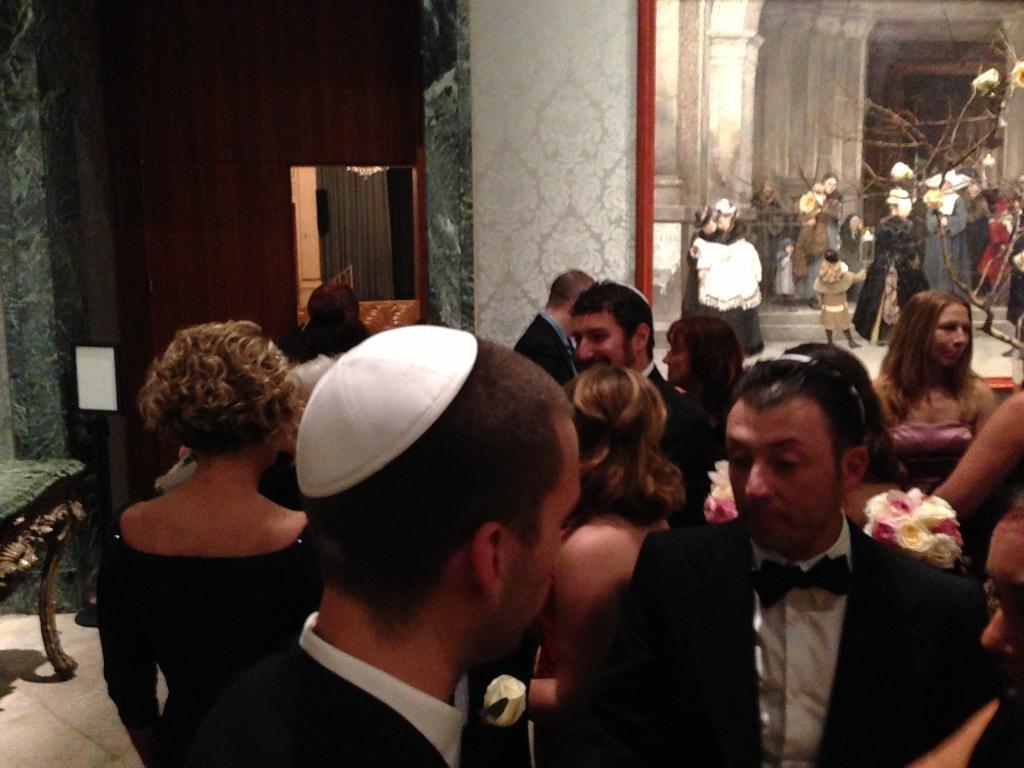How many people are in the image? There is a group of people in the image, but the exact number is not specified. What type of flora can be seen in the image? There are flowers and branches visible in the image. What type of structure is present in the image? There are walls in the image, which suggests a room or enclosed space. What object might be used for personal grooming or reflection in the image? There is a mirror in the image. What other unspecified objects can be seen in the image? There are some unspecified objects in the image, but their nature or purpose is not clear. What type of throne is visible in the image? There is no throne present in the image. What type of pet can be seen interacting with the people in the image? There is no pet visible in the image. 